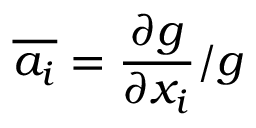Convert formula to latex. <formula><loc_0><loc_0><loc_500><loc_500>\overline { { a _ { i } } } = \frac { \partial g } { \partial x _ { i } } / g</formula> 